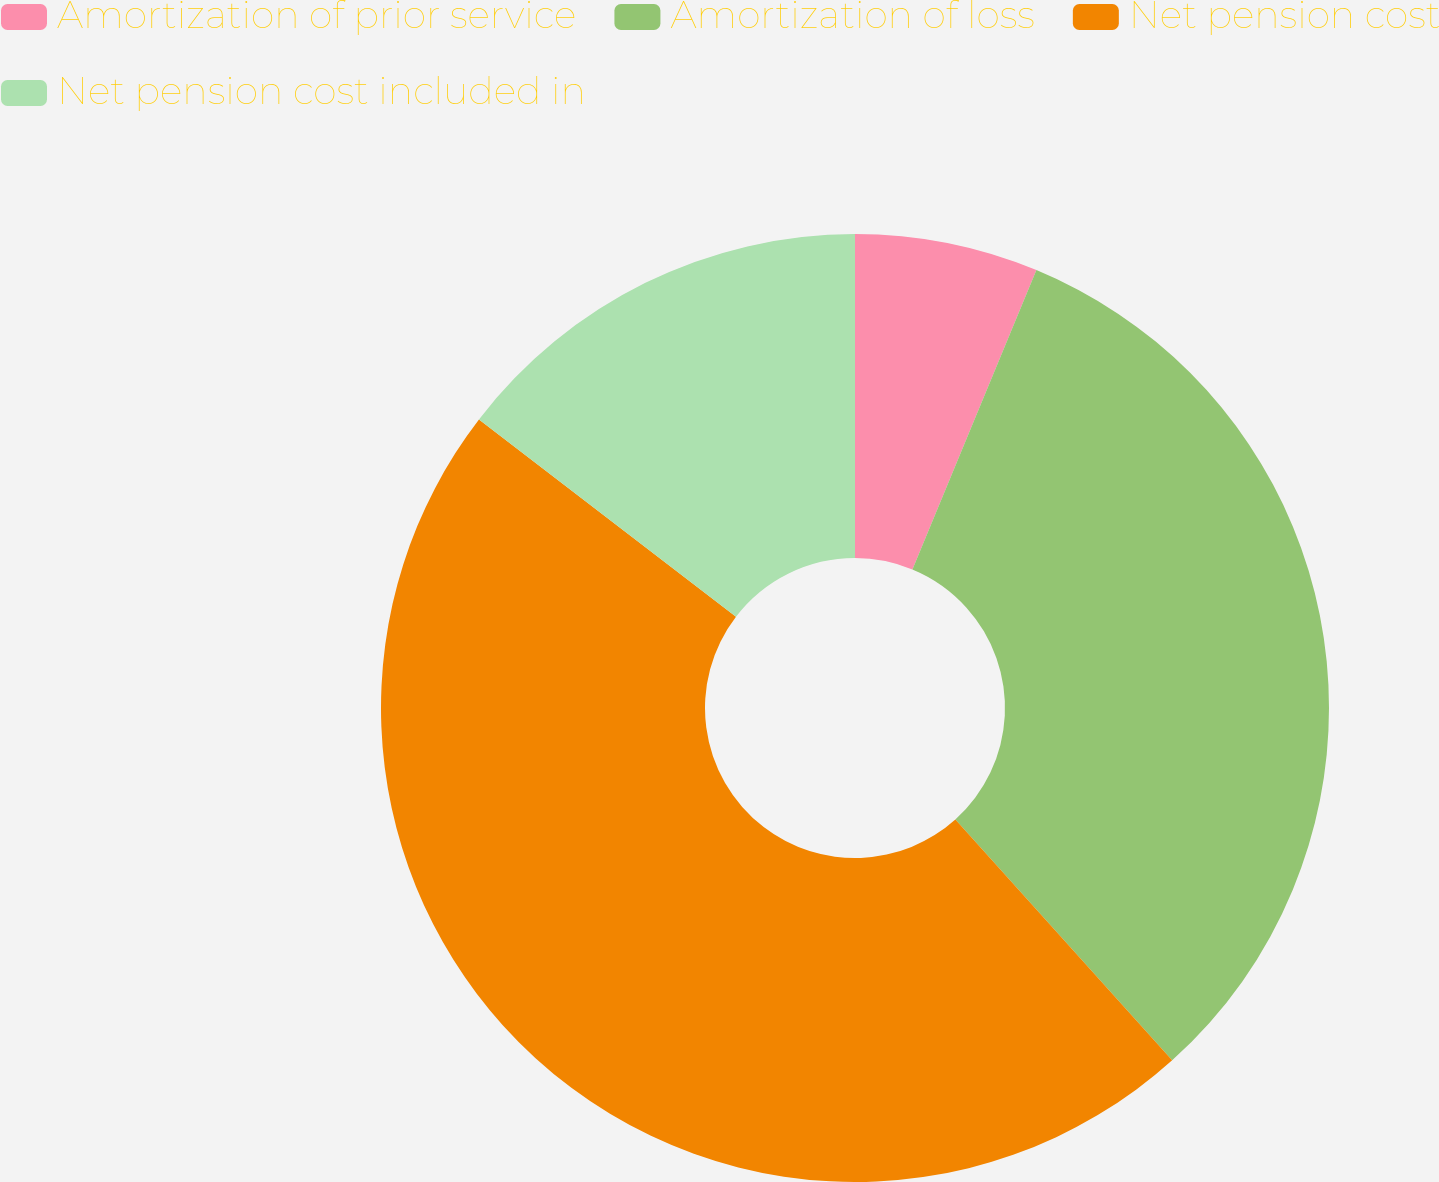<chart> <loc_0><loc_0><loc_500><loc_500><pie_chart><fcel>Amortization of prior service<fcel>Amortization of loss<fcel>Net pension cost<fcel>Net pension cost included in<nl><fcel>6.25%<fcel>32.08%<fcel>47.08%<fcel>14.58%<nl></chart> 